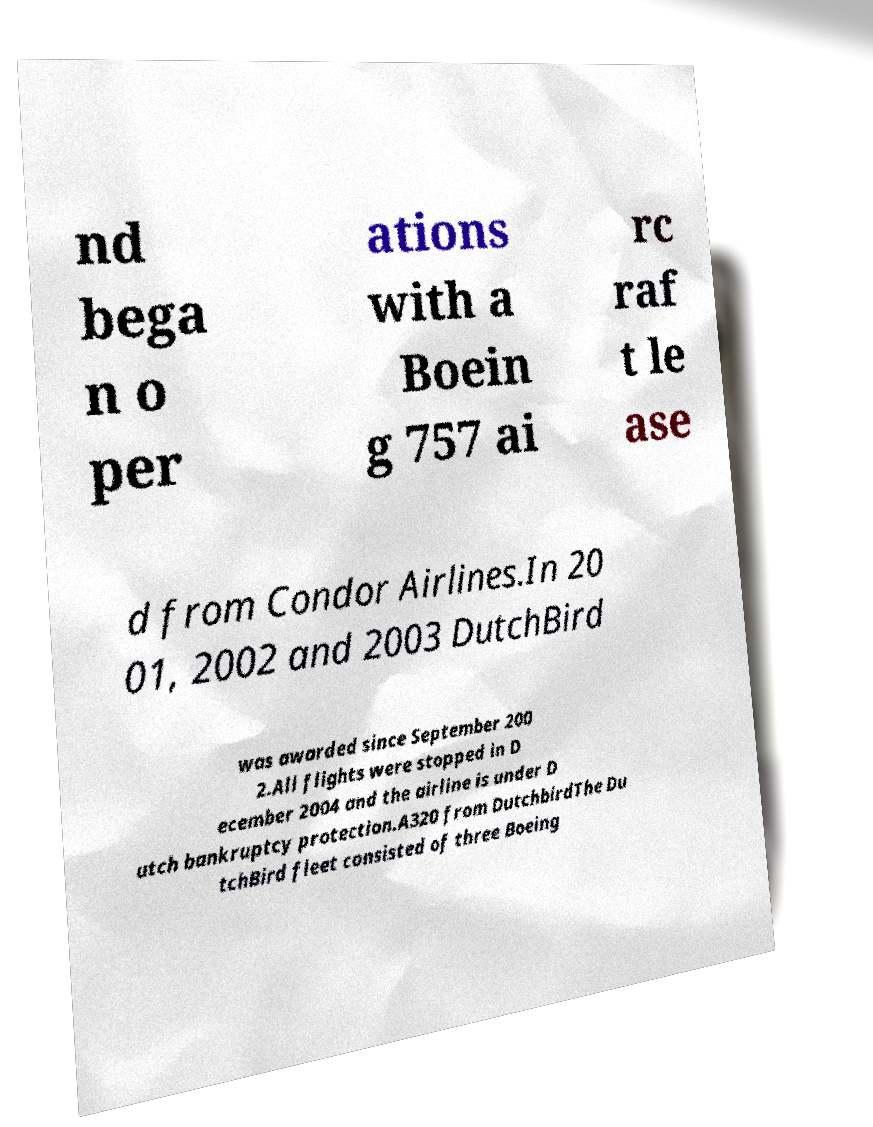What messages or text are displayed in this image? I need them in a readable, typed format. nd bega n o per ations with a Boein g 757 ai rc raf t le ase d from Condor Airlines.In 20 01, 2002 and 2003 DutchBird was awarded since September 200 2.All flights were stopped in D ecember 2004 and the airline is under D utch bankruptcy protection.A320 from DutchbirdThe Du tchBird fleet consisted of three Boeing 